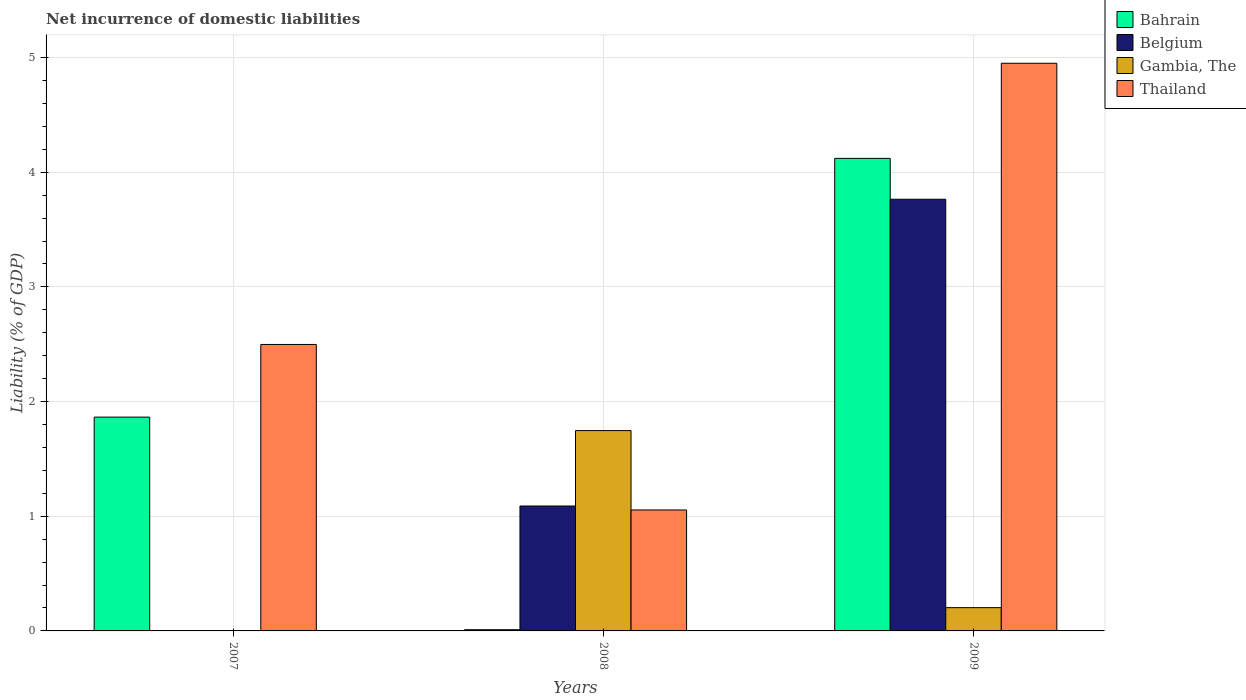Are the number of bars per tick equal to the number of legend labels?
Make the answer very short. No. Are the number of bars on each tick of the X-axis equal?
Make the answer very short. No. How many bars are there on the 1st tick from the left?
Your response must be concise. 2. Across all years, what is the maximum net incurrence of domestic liabilities in Thailand?
Your answer should be very brief. 4.95. Across all years, what is the minimum net incurrence of domestic liabilities in Belgium?
Ensure brevity in your answer.  0. What is the total net incurrence of domestic liabilities in Thailand in the graph?
Offer a very short reply. 8.5. What is the difference between the net incurrence of domestic liabilities in Thailand in 2007 and that in 2008?
Make the answer very short. 1.44. What is the difference between the net incurrence of domestic liabilities in Gambia, The in 2007 and the net incurrence of domestic liabilities in Thailand in 2009?
Offer a terse response. -4.95. What is the average net incurrence of domestic liabilities in Belgium per year?
Offer a very short reply. 1.62. In the year 2009, what is the difference between the net incurrence of domestic liabilities in Bahrain and net incurrence of domestic liabilities in Gambia, The?
Offer a very short reply. 3.92. What is the ratio of the net incurrence of domestic liabilities in Thailand in 2007 to that in 2008?
Make the answer very short. 2.37. Is the difference between the net incurrence of domestic liabilities in Bahrain in 2008 and 2009 greater than the difference between the net incurrence of domestic liabilities in Gambia, The in 2008 and 2009?
Make the answer very short. No. What is the difference between the highest and the second highest net incurrence of domestic liabilities in Thailand?
Offer a very short reply. 2.45. What is the difference between the highest and the lowest net incurrence of domestic liabilities in Bahrain?
Ensure brevity in your answer.  4.11. How many bars are there?
Keep it short and to the point. 10. How many years are there in the graph?
Your answer should be very brief. 3. What is the difference between two consecutive major ticks on the Y-axis?
Provide a short and direct response. 1. Are the values on the major ticks of Y-axis written in scientific E-notation?
Your response must be concise. No. Does the graph contain any zero values?
Provide a succinct answer. Yes. What is the title of the graph?
Offer a terse response. Net incurrence of domestic liabilities. Does "Greenland" appear as one of the legend labels in the graph?
Ensure brevity in your answer.  No. What is the label or title of the X-axis?
Make the answer very short. Years. What is the label or title of the Y-axis?
Give a very brief answer. Liability (% of GDP). What is the Liability (% of GDP) of Bahrain in 2007?
Give a very brief answer. 1.86. What is the Liability (% of GDP) of Thailand in 2007?
Offer a terse response. 2.5. What is the Liability (% of GDP) in Bahrain in 2008?
Your answer should be compact. 0.01. What is the Liability (% of GDP) of Belgium in 2008?
Your answer should be compact. 1.09. What is the Liability (% of GDP) of Gambia, The in 2008?
Your response must be concise. 1.75. What is the Liability (% of GDP) in Thailand in 2008?
Provide a short and direct response. 1.05. What is the Liability (% of GDP) in Bahrain in 2009?
Your answer should be very brief. 4.12. What is the Liability (% of GDP) of Belgium in 2009?
Offer a terse response. 3.76. What is the Liability (% of GDP) in Gambia, The in 2009?
Provide a short and direct response. 0.2. What is the Liability (% of GDP) of Thailand in 2009?
Provide a short and direct response. 4.95. Across all years, what is the maximum Liability (% of GDP) of Bahrain?
Provide a succinct answer. 4.12. Across all years, what is the maximum Liability (% of GDP) in Belgium?
Provide a short and direct response. 3.76. Across all years, what is the maximum Liability (% of GDP) of Gambia, The?
Provide a short and direct response. 1.75. Across all years, what is the maximum Liability (% of GDP) of Thailand?
Give a very brief answer. 4.95. Across all years, what is the minimum Liability (% of GDP) in Bahrain?
Give a very brief answer. 0.01. Across all years, what is the minimum Liability (% of GDP) in Gambia, The?
Offer a very short reply. 0. Across all years, what is the minimum Liability (% of GDP) of Thailand?
Provide a short and direct response. 1.05. What is the total Liability (% of GDP) of Bahrain in the graph?
Provide a succinct answer. 6. What is the total Liability (% of GDP) in Belgium in the graph?
Offer a very short reply. 4.85. What is the total Liability (% of GDP) of Gambia, The in the graph?
Your response must be concise. 1.95. What is the total Liability (% of GDP) of Thailand in the graph?
Give a very brief answer. 8.5. What is the difference between the Liability (% of GDP) in Bahrain in 2007 and that in 2008?
Ensure brevity in your answer.  1.85. What is the difference between the Liability (% of GDP) in Thailand in 2007 and that in 2008?
Your answer should be compact. 1.44. What is the difference between the Liability (% of GDP) of Bahrain in 2007 and that in 2009?
Keep it short and to the point. -2.26. What is the difference between the Liability (% of GDP) of Thailand in 2007 and that in 2009?
Offer a very short reply. -2.45. What is the difference between the Liability (% of GDP) in Bahrain in 2008 and that in 2009?
Provide a short and direct response. -4.11. What is the difference between the Liability (% of GDP) of Belgium in 2008 and that in 2009?
Your answer should be compact. -2.67. What is the difference between the Liability (% of GDP) of Gambia, The in 2008 and that in 2009?
Keep it short and to the point. 1.54. What is the difference between the Liability (% of GDP) in Thailand in 2008 and that in 2009?
Ensure brevity in your answer.  -3.9. What is the difference between the Liability (% of GDP) of Bahrain in 2007 and the Liability (% of GDP) of Belgium in 2008?
Offer a terse response. 0.78. What is the difference between the Liability (% of GDP) of Bahrain in 2007 and the Liability (% of GDP) of Gambia, The in 2008?
Make the answer very short. 0.12. What is the difference between the Liability (% of GDP) in Bahrain in 2007 and the Liability (% of GDP) in Thailand in 2008?
Offer a terse response. 0.81. What is the difference between the Liability (% of GDP) of Bahrain in 2007 and the Liability (% of GDP) of Belgium in 2009?
Provide a short and direct response. -1.9. What is the difference between the Liability (% of GDP) of Bahrain in 2007 and the Liability (% of GDP) of Gambia, The in 2009?
Make the answer very short. 1.66. What is the difference between the Liability (% of GDP) of Bahrain in 2007 and the Liability (% of GDP) of Thailand in 2009?
Give a very brief answer. -3.09. What is the difference between the Liability (% of GDP) in Bahrain in 2008 and the Liability (% of GDP) in Belgium in 2009?
Your response must be concise. -3.75. What is the difference between the Liability (% of GDP) of Bahrain in 2008 and the Liability (% of GDP) of Gambia, The in 2009?
Give a very brief answer. -0.19. What is the difference between the Liability (% of GDP) of Bahrain in 2008 and the Liability (% of GDP) of Thailand in 2009?
Make the answer very short. -4.94. What is the difference between the Liability (% of GDP) in Belgium in 2008 and the Liability (% of GDP) in Gambia, The in 2009?
Give a very brief answer. 0.89. What is the difference between the Liability (% of GDP) in Belgium in 2008 and the Liability (% of GDP) in Thailand in 2009?
Provide a short and direct response. -3.86. What is the difference between the Liability (% of GDP) in Gambia, The in 2008 and the Liability (% of GDP) in Thailand in 2009?
Ensure brevity in your answer.  -3.2. What is the average Liability (% of GDP) of Bahrain per year?
Your response must be concise. 2. What is the average Liability (% of GDP) of Belgium per year?
Provide a short and direct response. 1.62. What is the average Liability (% of GDP) in Gambia, The per year?
Give a very brief answer. 0.65. What is the average Liability (% of GDP) of Thailand per year?
Ensure brevity in your answer.  2.83. In the year 2007, what is the difference between the Liability (% of GDP) in Bahrain and Liability (% of GDP) in Thailand?
Provide a succinct answer. -0.63. In the year 2008, what is the difference between the Liability (% of GDP) of Bahrain and Liability (% of GDP) of Belgium?
Your answer should be compact. -1.08. In the year 2008, what is the difference between the Liability (% of GDP) in Bahrain and Liability (% of GDP) in Gambia, The?
Keep it short and to the point. -1.74. In the year 2008, what is the difference between the Liability (% of GDP) in Bahrain and Liability (% of GDP) in Thailand?
Provide a succinct answer. -1.04. In the year 2008, what is the difference between the Liability (% of GDP) in Belgium and Liability (% of GDP) in Gambia, The?
Your answer should be very brief. -0.66. In the year 2008, what is the difference between the Liability (% of GDP) of Belgium and Liability (% of GDP) of Thailand?
Ensure brevity in your answer.  0.03. In the year 2008, what is the difference between the Liability (% of GDP) in Gambia, The and Liability (% of GDP) in Thailand?
Your answer should be compact. 0.69. In the year 2009, what is the difference between the Liability (% of GDP) of Bahrain and Liability (% of GDP) of Belgium?
Make the answer very short. 0.36. In the year 2009, what is the difference between the Liability (% of GDP) of Bahrain and Liability (% of GDP) of Gambia, The?
Provide a succinct answer. 3.92. In the year 2009, what is the difference between the Liability (% of GDP) in Bahrain and Liability (% of GDP) in Thailand?
Keep it short and to the point. -0.83. In the year 2009, what is the difference between the Liability (% of GDP) of Belgium and Liability (% of GDP) of Gambia, The?
Your answer should be very brief. 3.56. In the year 2009, what is the difference between the Liability (% of GDP) of Belgium and Liability (% of GDP) of Thailand?
Make the answer very short. -1.19. In the year 2009, what is the difference between the Liability (% of GDP) of Gambia, The and Liability (% of GDP) of Thailand?
Ensure brevity in your answer.  -4.75. What is the ratio of the Liability (% of GDP) in Bahrain in 2007 to that in 2008?
Offer a very short reply. 173.3. What is the ratio of the Liability (% of GDP) in Thailand in 2007 to that in 2008?
Your answer should be compact. 2.37. What is the ratio of the Liability (% of GDP) in Bahrain in 2007 to that in 2009?
Give a very brief answer. 0.45. What is the ratio of the Liability (% of GDP) in Thailand in 2007 to that in 2009?
Your response must be concise. 0.5. What is the ratio of the Liability (% of GDP) of Bahrain in 2008 to that in 2009?
Keep it short and to the point. 0. What is the ratio of the Liability (% of GDP) of Belgium in 2008 to that in 2009?
Ensure brevity in your answer.  0.29. What is the ratio of the Liability (% of GDP) of Gambia, The in 2008 to that in 2009?
Your response must be concise. 8.61. What is the ratio of the Liability (% of GDP) in Thailand in 2008 to that in 2009?
Offer a very short reply. 0.21. What is the difference between the highest and the second highest Liability (% of GDP) of Bahrain?
Offer a very short reply. 2.26. What is the difference between the highest and the second highest Liability (% of GDP) in Thailand?
Offer a very short reply. 2.45. What is the difference between the highest and the lowest Liability (% of GDP) in Bahrain?
Your answer should be very brief. 4.11. What is the difference between the highest and the lowest Liability (% of GDP) of Belgium?
Ensure brevity in your answer.  3.76. What is the difference between the highest and the lowest Liability (% of GDP) of Gambia, The?
Keep it short and to the point. 1.75. What is the difference between the highest and the lowest Liability (% of GDP) of Thailand?
Offer a terse response. 3.9. 